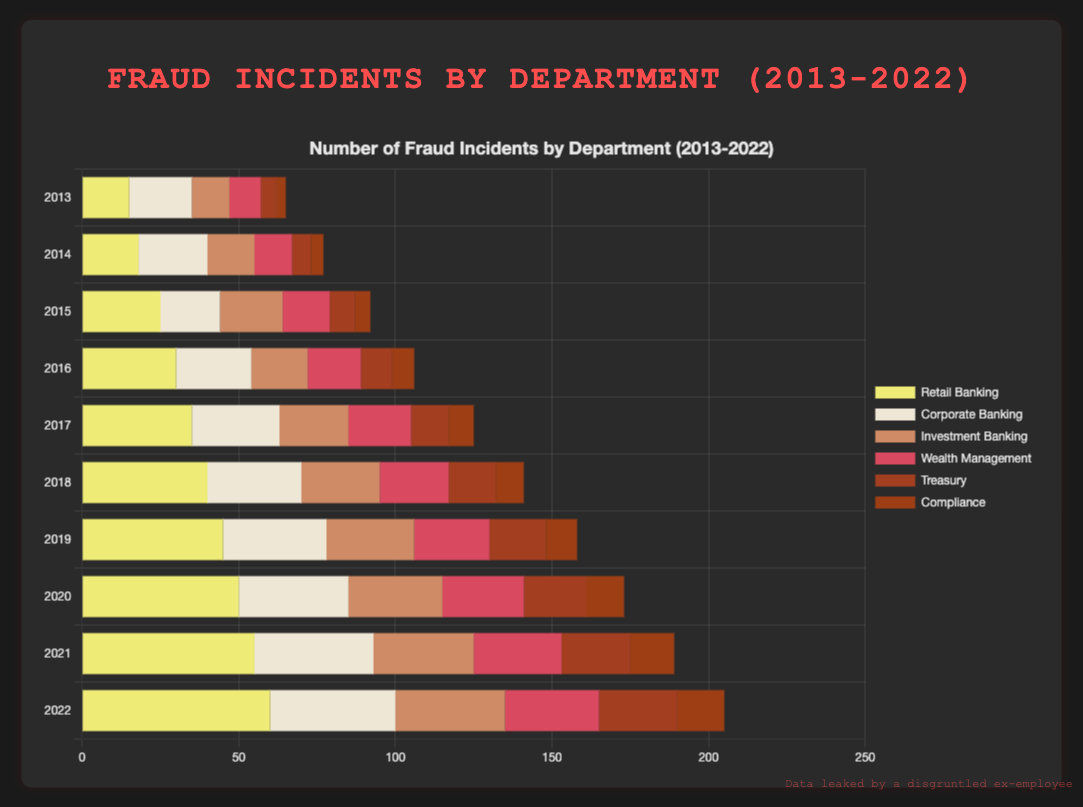Which department reported the highest number of fraud incidents in 2022? Observe the heights of the bars for the year 2022 across all departments. The highest bar corresponds to the department with the most incidents.
Answer: Retail Banking What is the total number of fraud incidents reported by all departments combined in 2015? Sum up the values from all departments for the year 2015: (25 + 19 + 20 + 15 + 8 + 5).
Answer: 92 How did the number of fraud incidents in Corporate Banking change from 2013 to 2022? Calculate the difference: in 2022, Corporate Banking reported 40 incidents, and in 2013, it reported 20 incidents. The change is 40 - 20.
Answer: Increased by 20 Which year had the lowest total number of fraud incidents reported across all departments? Calculate the total number for each year and compare. 2013 has the lowest total (15 + 20 + 12 + 10 + 5 + 3 = 65).
Answer: 2013 What is the average number of fraud incidents reported by the Compliance department over the decade? Add the incidents by Compliance from 2013 to 2022, then divide by 10: (3 + 4 + 5 + 7 + 8 + 9 + 10 + 12 + 14 + 15) / 10.
Answer: 8.7 Compare the total number of fraud incidents reported in Wealth Management from 2013-2017 vs. 2018-2022. Which period had more incidents? Sum the values for each period: 2013-2017 (10 + 12 + 15 + 17 + 20) = 74, 2018-2022 (22 + 24 + 26 + 28 + 30) = 130.
Answer: 2018-2022 Which department shows a steady increase in fraud incidents each year from 2013 to 2022? Examine the data for each department across the years; Retail Banking shows a steady increase each year.
Answer: Retail Banking What is the difference in the number of fraud incidents between Investment Banking and Treasury in 2022? Subtract the number of incidents in Treasury from those in Investment Banking for 2022: 35 - 25.
Answer: 10 How many more fraud incidents did Corporate Banking report in 2020 compared to 2014? Subtract the number of fraud incidents in 2014 from those in 2020 for Corporate Banking: 35 - 22.
Answer: 13 